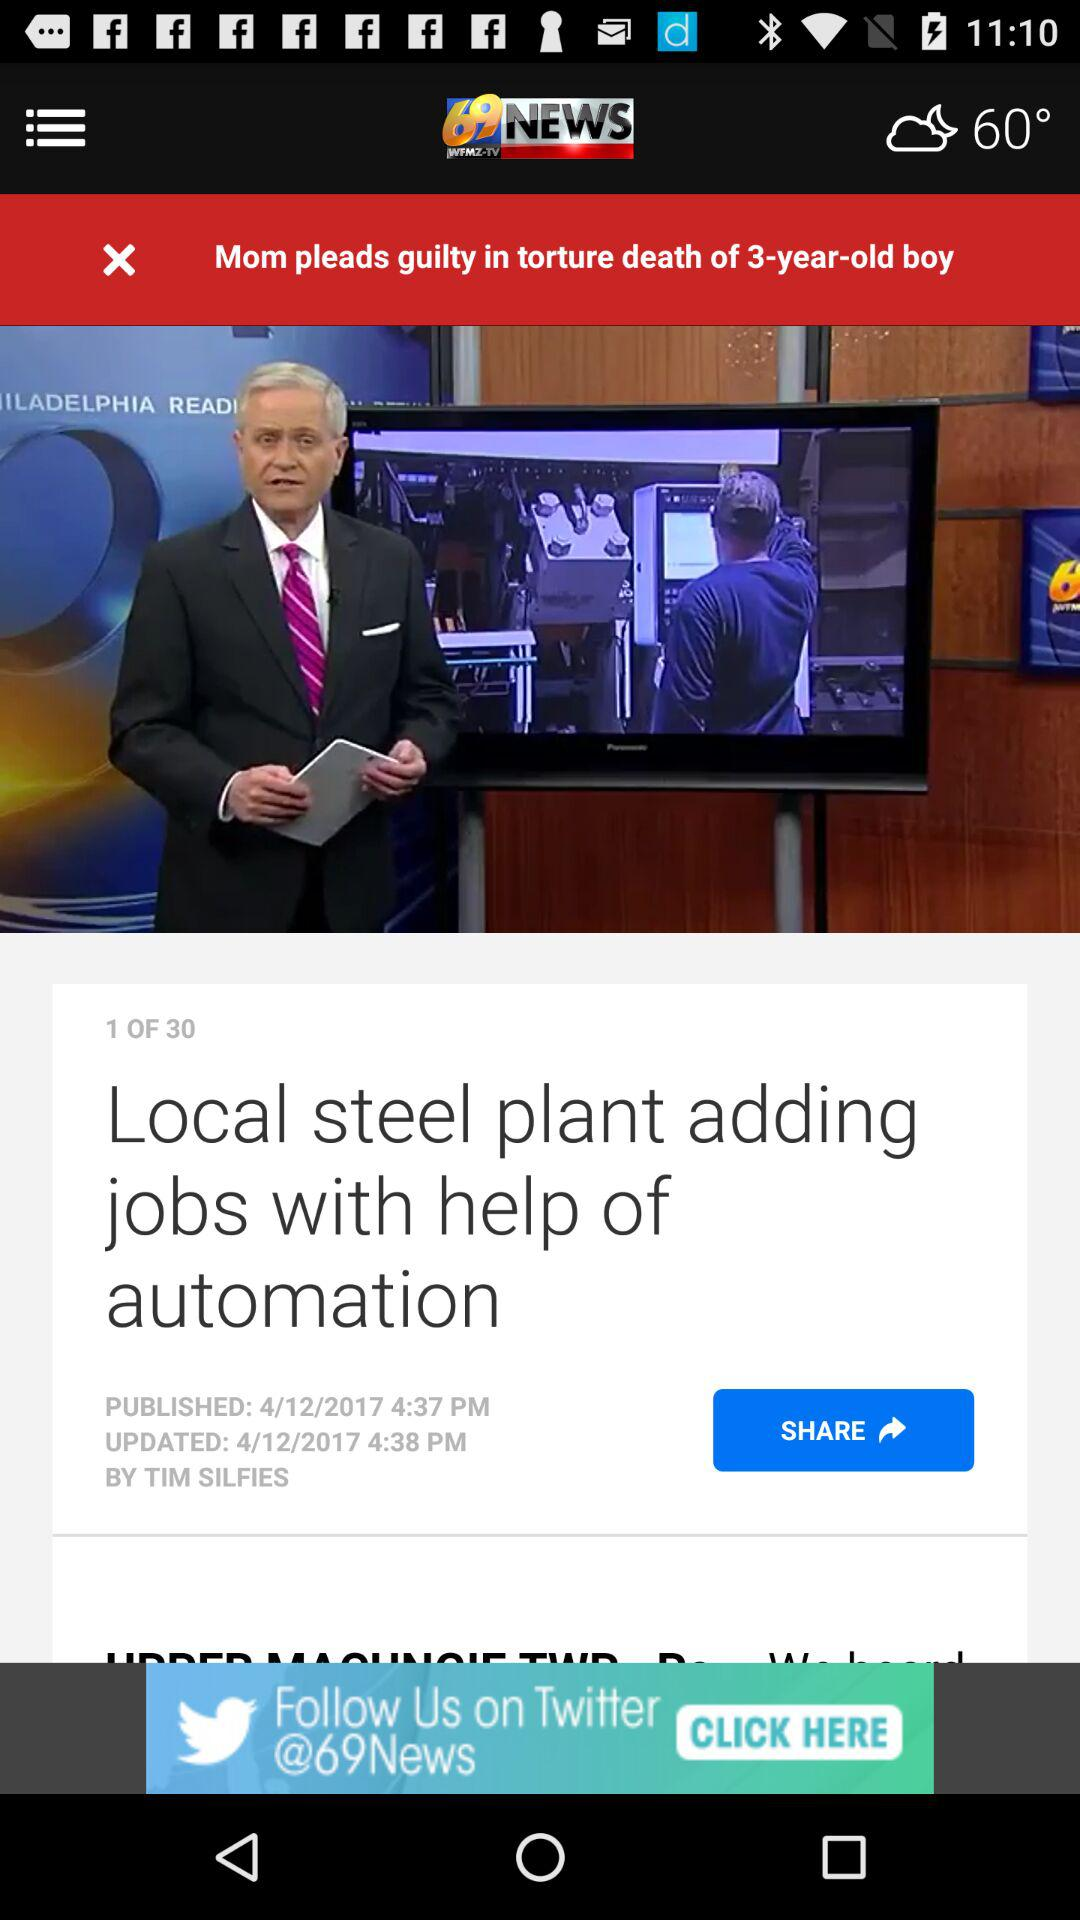What is the temperature shown on the screen? The temperature shown on the screen is 60°. 